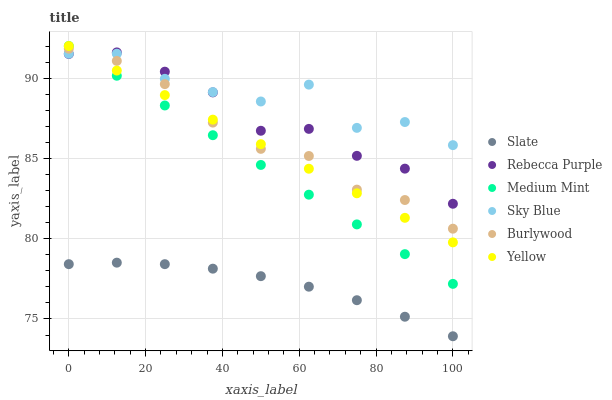Does Slate have the minimum area under the curve?
Answer yes or no. Yes. Does Sky Blue have the maximum area under the curve?
Answer yes or no. Yes. Does Burlywood have the minimum area under the curve?
Answer yes or no. No. Does Burlywood have the maximum area under the curve?
Answer yes or no. No. Is Medium Mint the smoothest?
Answer yes or no. Yes. Is Sky Blue the roughest?
Answer yes or no. Yes. Is Burlywood the smoothest?
Answer yes or no. No. Is Burlywood the roughest?
Answer yes or no. No. Does Slate have the lowest value?
Answer yes or no. Yes. Does Burlywood have the lowest value?
Answer yes or no. No. Does Yellow have the highest value?
Answer yes or no. Yes. Does Burlywood have the highest value?
Answer yes or no. No. Is Slate less than Yellow?
Answer yes or no. Yes. Is Sky Blue greater than Slate?
Answer yes or no. Yes. Does Yellow intersect Sky Blue?
Answer yes or no. Yes. Is Yellow less than Sky Blue?
Answer yes or no. No. Is Yellow greater than Sky Blue?
Answer yes or no. No. Does Slate intersect Yellow?
Answer yes or no. No. 